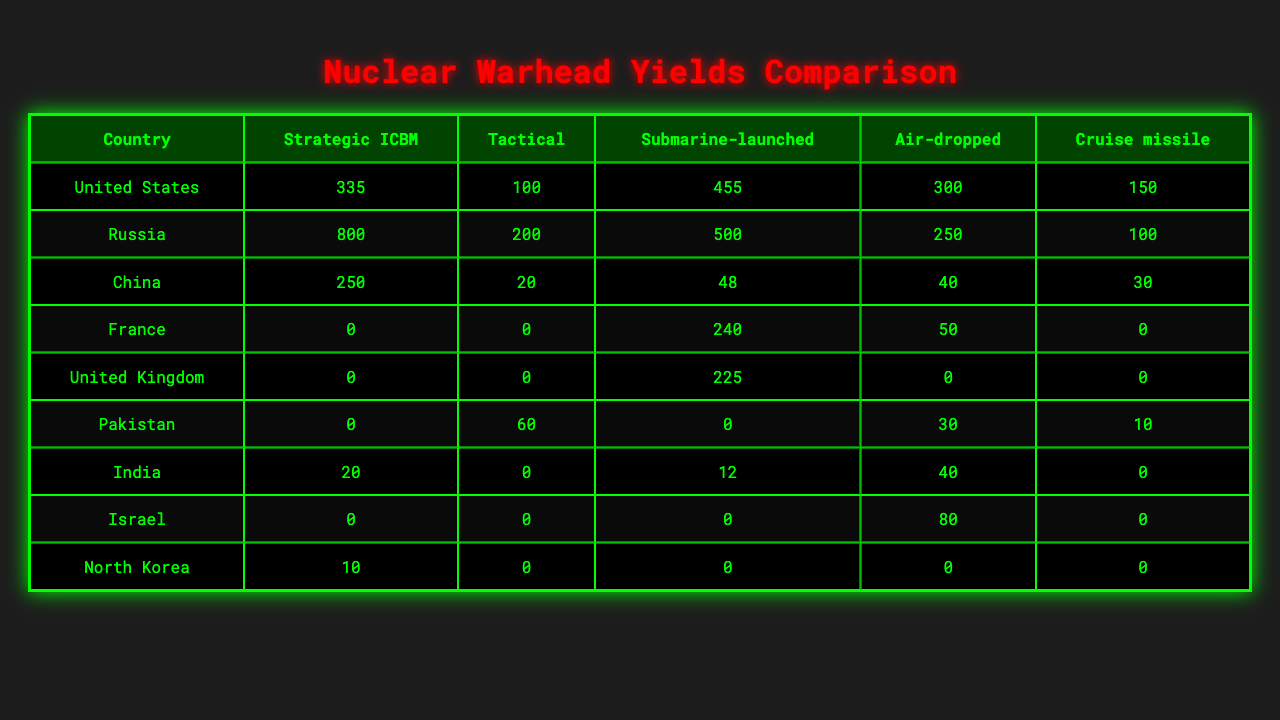What is the yield of Russia's Strategic ICBM warheads? According to the table, Russia's Strategic ICBM yield is listed as 800.
Answer: 800 Which country has the highest yield for Submarine-launched warheads? Looking at the Submarine-launched column, Russia has the highest yield with 500.
Answer: Russia What is the total yield of Tactical warheads for the United States and Russia combined? The yield for the United States is 100 and for Russia is 200. Adding these yields together gives 100 + 200 = 300.
Answer: 300 Does Israel have any yield for Submarine-launched warheads? Referring to the table, Israel's yield for Submarine-launched warheads is listed as 0.
Answer: No Which country has the lowest yield for Air-dropped warheads? The Air-dropped yield values in the table show North Korea with a yield of 0, which is the lowest.
Answer: North Korea What is the average yield of the Submarine-launched warheads across all countries? The yields for Submarine-launched warheads are 455 (USA), 500 (Russia), 48 (China), 240 (France), 225 (UK), 0 (Pakistan), 12 (India), 0 (Israel), 0 (North Korea). Summing these yields gives 455 + 500 + 48 + 240 + 225 + 0 + 12 + 0 + 0 = 1480. There are 9 values, so the average is 1480/9 = approximately 164.44.
Answer: 164.44 Which type of warhead yields more for Pakistan: Tactical or Air-dropped? Pakistan has 60 yield for Tactical warheads and 30 yield for Air-dropped. Since 60 is greater than 30, Tactical yields more.
Answer: Tactical What is the total yield of all types of warheads for France? According to the table, France has yields of 0 (Strategic ICBM), 0 (Tactical), 240 (Submarine-launched), 50 (Air-dropped), and 0 (Cruise missile). The total yield is 0 + 0 + 240 + 50 + 0 = 290.
Answer: 290 Which country has the same yield for Tactical and Air-dropped warheads? Referring to the table, Pakistan has a yield of 60 for Tactical and 30 for Air-dropped, which are not equal. The same applies for others, and the only country with yields of 0 for Tactical and Air-dropped is both France and the UK.
Answer: France and United Kingdom Is there any country with a yield greater than 300 in Air-dropped warheads? Looking at the Air-dropped warheads, the highest yield is 300 (USA), which meets the criteria.
Answer: Yes What is the difference in yield between the highest and lowest countries for Strategic ICBM warheads? The highest yield is 800 (Russia) and the lowest is 0 (France, UK, Israel), giving a difference of 800 - 0 = 800.
Answer: 800 